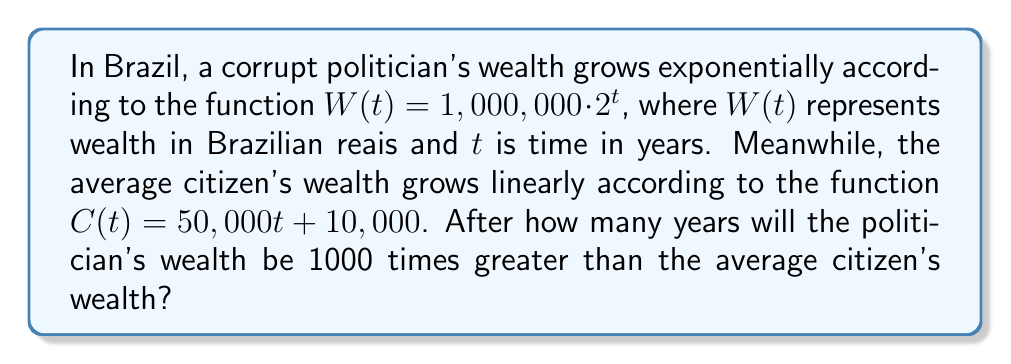Show me your answer to this math problem. Let's approach this step-by-step:

1) We need to find $t$ when $W(t) = 1000 \cdot C(t)$

2) Substituting the functions:
   $1,000,000 \cdot 2^t = 1000 \cdot (50,000t + 10,000)$

3) Simplify the right side:
   $1,000,000 \cdot 2^t = 50,000,000t + 10,000,000$

4) Divide both sides by 1,000,000:
   $2^t = 50t + 10$

5) Now we need to use logarithms to solve for $t$. Let's take $\log_2$ of both sides:
   $\log_2(2^t) = \log_2(50t + 10)$

6) Simplify the left side using the logarithm property $\log_a(a^x) = x$:
   $t = \log_2(50t + 10)$

7) This equation can't be solved algebraically. We need to use numerical methods or graphing to find the solution.

8) Using a graphing calculator or computer software, we can find that the solution is approximately $t \approx 15.55$ years.

9) Since we're dealing with whole years, we round up to 16 years.
Answer: 16 years 